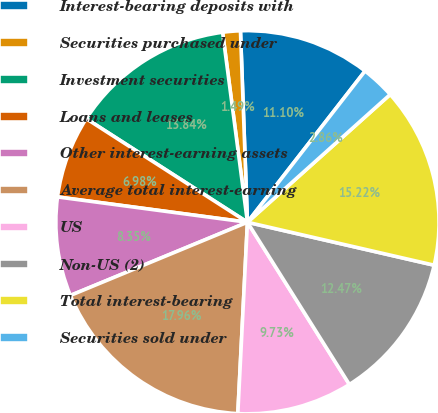Convert chart to OTSL. <chart><loc_0><loc_0><loc_500><loc_500><pie_chart><fcel>Interest-bearing deposits with<fcel>Securities purchased under<fcel>Investment securities<fcel>Loans and leases<fcel>Other interest-earning assets<fcel>Average total interest-earning<fcel>US<fcel>Non-US (2)<fcel>Total interest-bearing<fcel>Securities sold under<nl><fcel>11.1%<fcel>1.49%<fcel>13.84%<fcel>6.98%<fcel>8.35%<fcel>17.96%<fcel>9.73%<fcel>12.47%<fcel>15.22%<fcel>2.86%<nl></chart> 